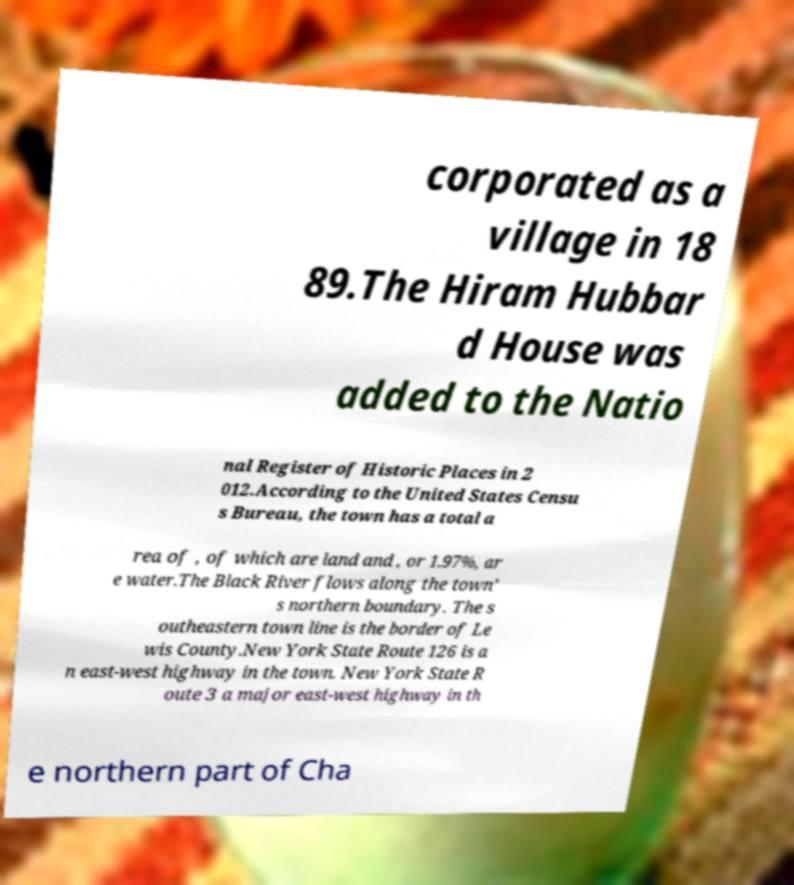Could you extract and type out the text from this image? corporated as a village in 18 89.The Hiram Hubbar d House was added to the Natio nal Register of Historic Places in 2 012.According to the United States Censu s Bureau, the town has a total a rea of , of which are land and , or 1.97%, ar e water.The Black River flows along the town' s northern boundary. The s outheastern town line is the border of Le wis County.New York State Route 126 is a n east-west highway in the town. New York State R oute 3 a major east-west highway in th e northern part of Cha 